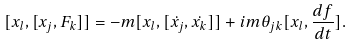<formula> <loc_0><loc_0><loc_500><loc_500>[ x _ { l } , [ x _ { j } , F _ { k } ] ] = - m [ x _ { l } , [ \dot { x _ { j } } , \dot { x _ { k } } ] ] + i m \theta _ { j k } [ x _ { l } , \frac { d f } { d t } ] .</formula> 